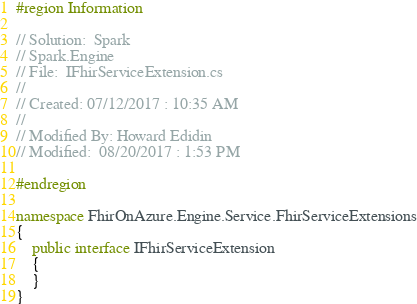<code> <loc_0><loc_0><loc_500><loc_500><_C#_>#region Information

// Solution:  Spark
// Spark.Engine
// File:  IFhirServiceExtension.cs
// 
// Created: 07/12/2017 : 10:35 AM
// 
// Modified By: Howard Edidin
// Modified:  08/20/2017 : 1:53 PM

#endregion

namespace FhirOnAzure.Engine.Service.FhirServiceExtensions
{
    public interface IFhirServiceExtension
    {
    }
}</code> 